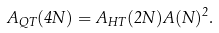<formula> <loc_0><loc_0><loc_500><loc_500>A _ { Q T } ( 4 N ) = A _ { H T } ( 2 N ) A ( N ) ^ { 2 } .</formula> 